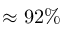<formula> <loc_0><loc_0><loc_500><loc_500>\approx 9 2 \%</formula> 